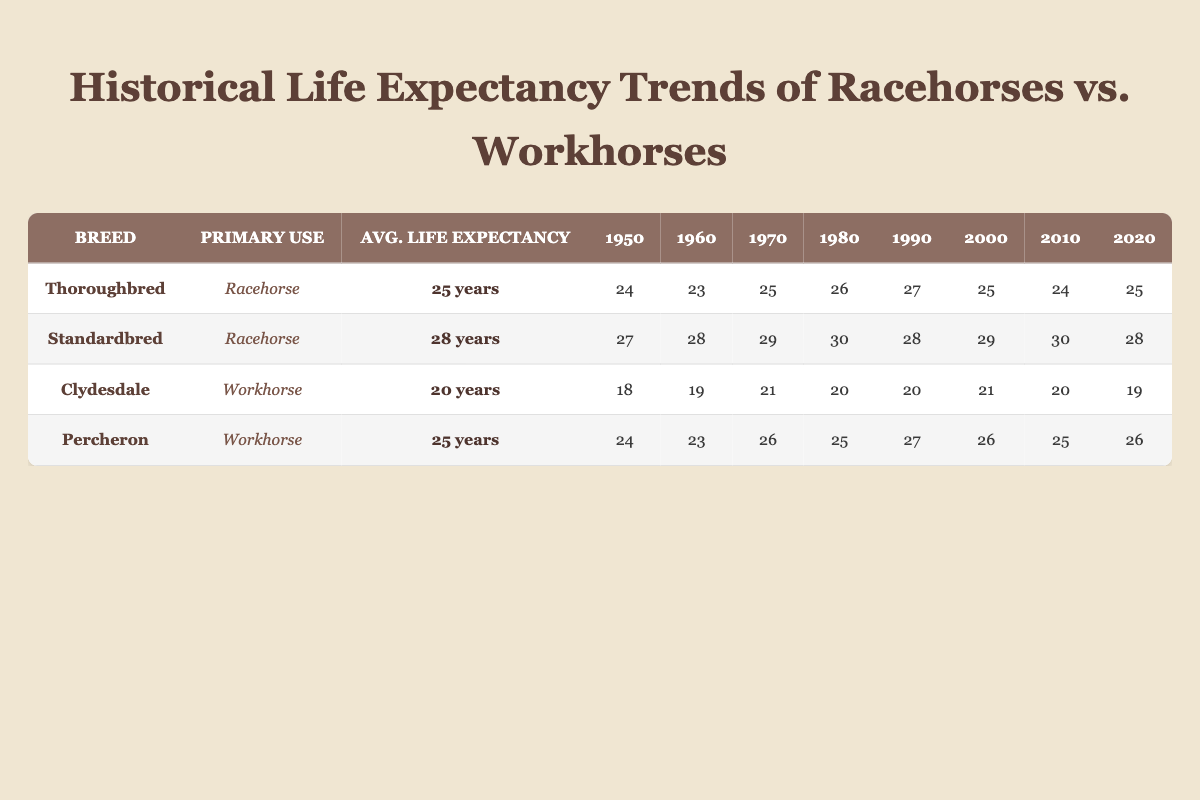What is the average life expectancy of Thoroughbreds? According to the table, the average life expectancy of Thoroughbreds is listed as 25 years.
Answer: 25 years In which year did Standardbreds show the highest life expectancy? By examining the historical data of Standardbreds, the year with the highest recorded life expectancy is 1980, when it reached 30 years.
Answer: 1980 Did Clydesdales have a longer average life expectancy than Thoroughbreds? The average life expectancy of Clydesdales is 20 years, whereas Thoroughbreds have an average life expectancy of 25 years, therefore Clydesdales did not surpass Thoroughbreds in this aspect.
Answer: No What was the life expectancy of Percherons in 1990? According to the provided data, Percherons had a life expectancy of 27 years in 1990.
Answer: 27 years Calculate the difference in average life expectancy between Standardbreds and Clydesdales. The average life expectancy of Standardbreds is 28 years while that of Clydesdales is 20 years. The difference is 28 - 20 = 8 years.
Answer: 8 years How many years did the life expectancy of Thoroughbreds drop between 1950 and 1960? The life expectancy of Thoroughbreds in 1950 was 24 years and in 1960 it was 23 years, showing a drop of 24 - 23 = 1 year.
Answer: 1 year Which breed experienced the greatest fluctuation in life expectancy over the decades? By reviewing the data, Standardbreds experienced varying life spans across the decades, with a maximum fluctuation of 3 years (from 30 years in 1980 to 28 years in 2020).
Answer: Standardbred Did any Workhorse breed maintain the same life expectancy from 2000 to 2020? The Percheron maintained consistent life expectancy at 26 years from 2000 to 2020, while Clydesdale dropped from 21 to 19 years.
Answer: Yes 